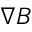<formula> <loc_0><loc_0><loc_500><loc_500>\nabla B</formula> 